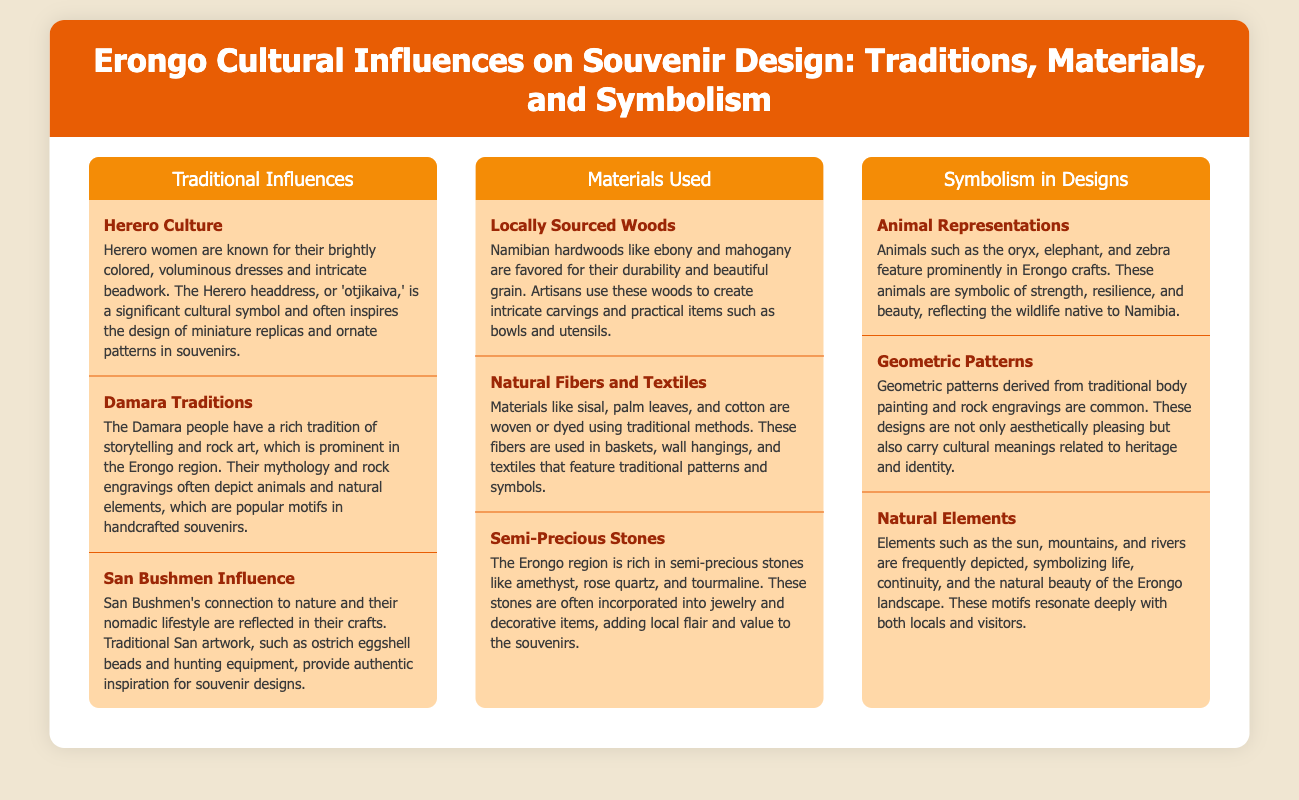What are the Herero women known for? The document states that Herero women are known for their brightly colored, voluminous dresses and intricate beadwork.
Answer: Brightly colored dresses and intricate beadwork What is a significant cultural symbol of the Herero culture? According to the document, the Herero headdress, or 'otjikaiva,' is a significant cultural symbol.
Answer: Otjikaiva Which traditional story is mentioned in relation to the Damara people? The document mentions that the Damara people have a rich tradition of storytelling and rock art.
Answer: Storytelling and rock art What material is favored for creating intricate carvings? The document specifies that Namibian hardwoods like ebony and mahogany are favored for their durability and beautiful grain.
Answer: Ebony and mahogany What natural fibers are used in traditional items? The document lists sisal, palm leaves, and cotton as materials woven or dyed using traditional methods.
Answer: Sisal, palm leaves, and cotton What type of stones are rich in the Erongo region? The document states that the Erongo region is rich in semi-precious stones like amethyst, rose quartz, and tourmaline.
Answer: Amethyst, rose quartz, and tourmaline What does the oryx symbolize in Erongo crafts? The document indicates that the oryx symbolizes strength, resilience, and beauty.
Answer: Strength, resilience, and beauty What patterns are derived from traditional body painting? According to the document, geometric patterns are derived from traditional body painting and rock engravings.
Answer: Geometric patterns What do natural elements like the sun and mountains symbolize? The document explains that elements such as the sun, mountains, and rivers symbolize life, continuity, and the natural beauty of the Erongo landscape.
Answer: Life, continuity, and natural beauty 